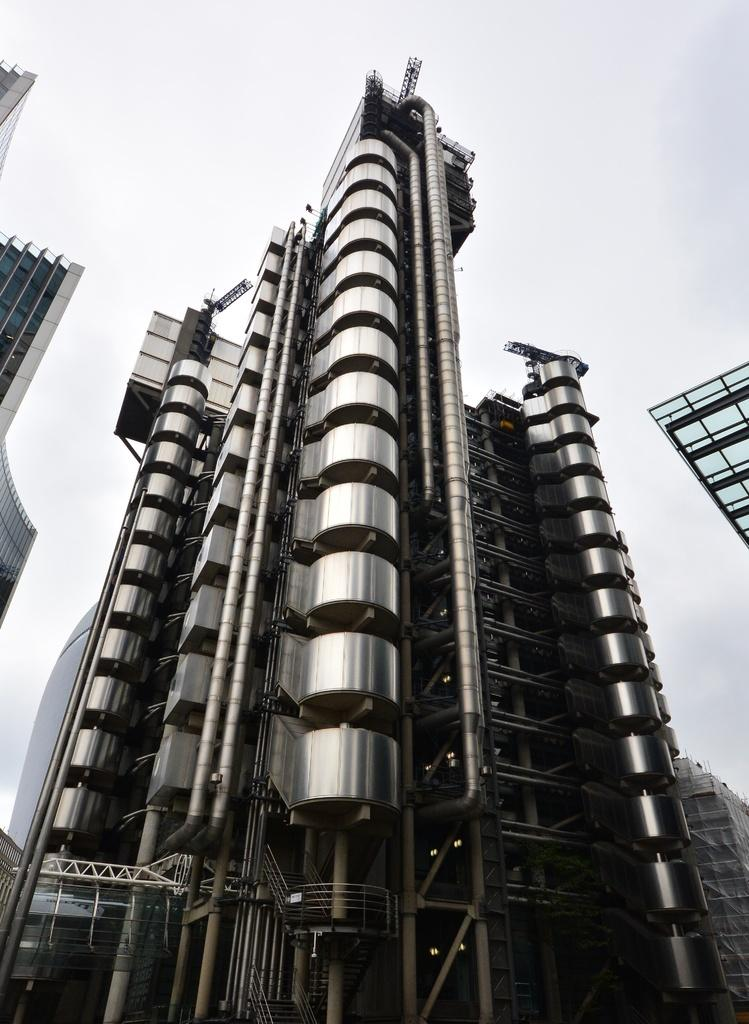What structures are visible in the image? There are buildings in the image. What is visible at the top of the image? The sky is visible at the top of the image. How many pages of a book can be seen in the image? There are no pages of a book present in the image. What type of vacation is depicted in the image? There is no vacation depicted in the image; it features buildings and the sky. 